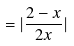<formula> <loc_0><loc_0><loc_500><loc_500>= | \frac { 2 - x } { 2 x } |</formula> 